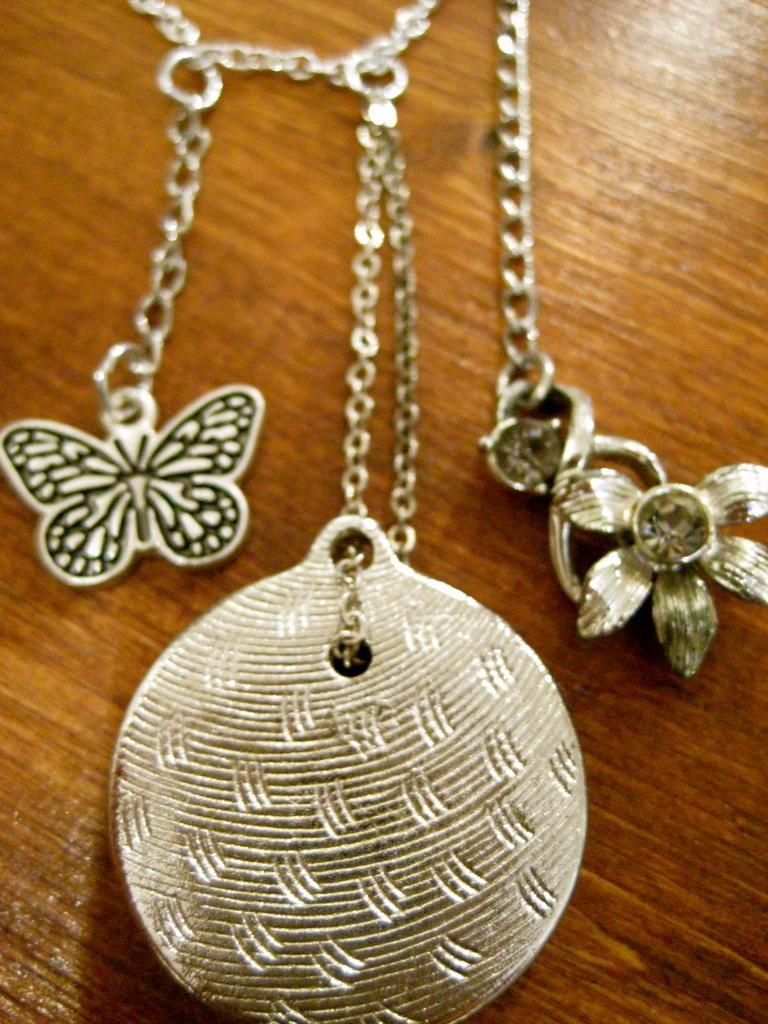Describe this image in one or two sentences. In this picture we can see lockets, chains on the wooden surface. 